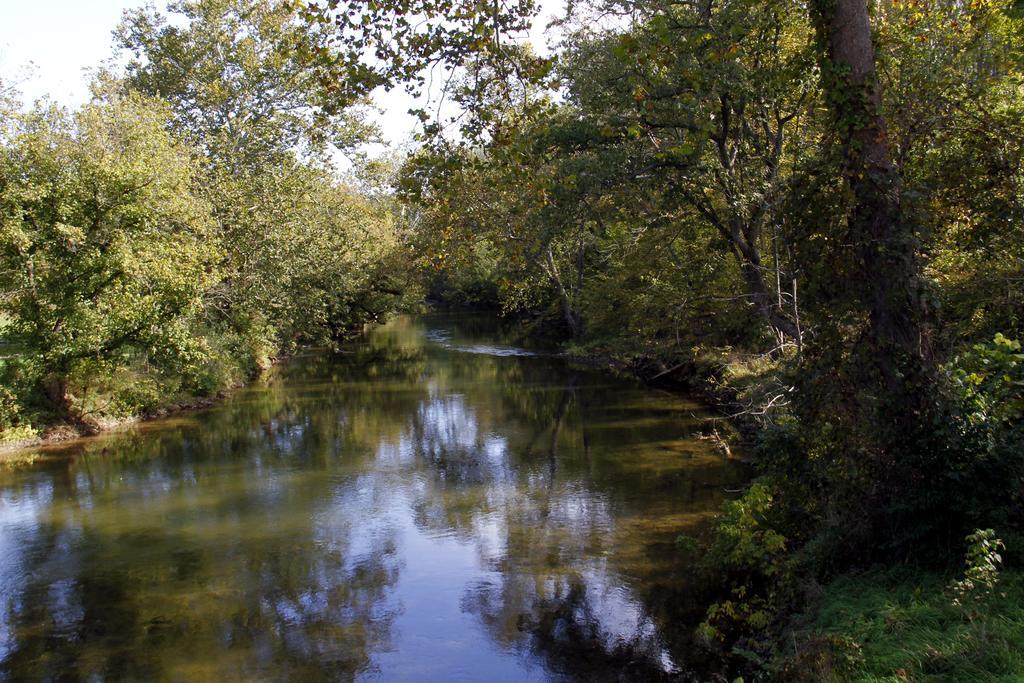Please provide a concise description of this image. In the picture I can see the water, trees, plants and the grass. In the background I can see the sky. 